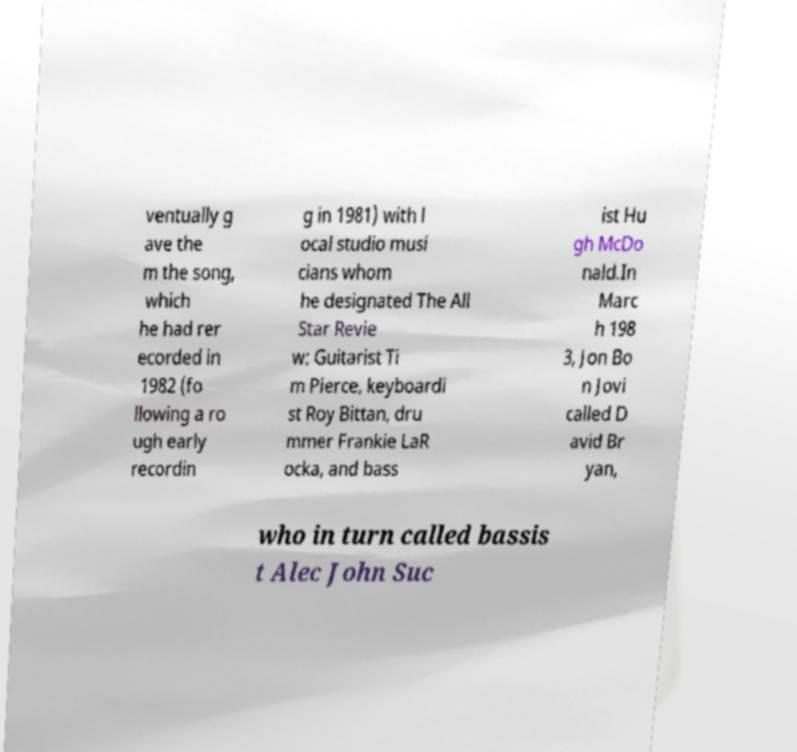Could you assist in decoding the text presented in this image and type it out clearly? ventually g ave the m the song, which he had rer ecorded in 1982 (fo llowing a ro ugh early recordin g in 1981) with l ocal studio musi cians whom he designated The All Star Revie w: Guitarist Ti m Pierce, keyboardi st Roy Bittan, dru mmer Frankie LaR ocka, and bass ist Hu gh McDo nald.In Marc h 198 3, Jon Bo n Jovi called D avid Br yan, who in turn called bassis t Alec John Suc 